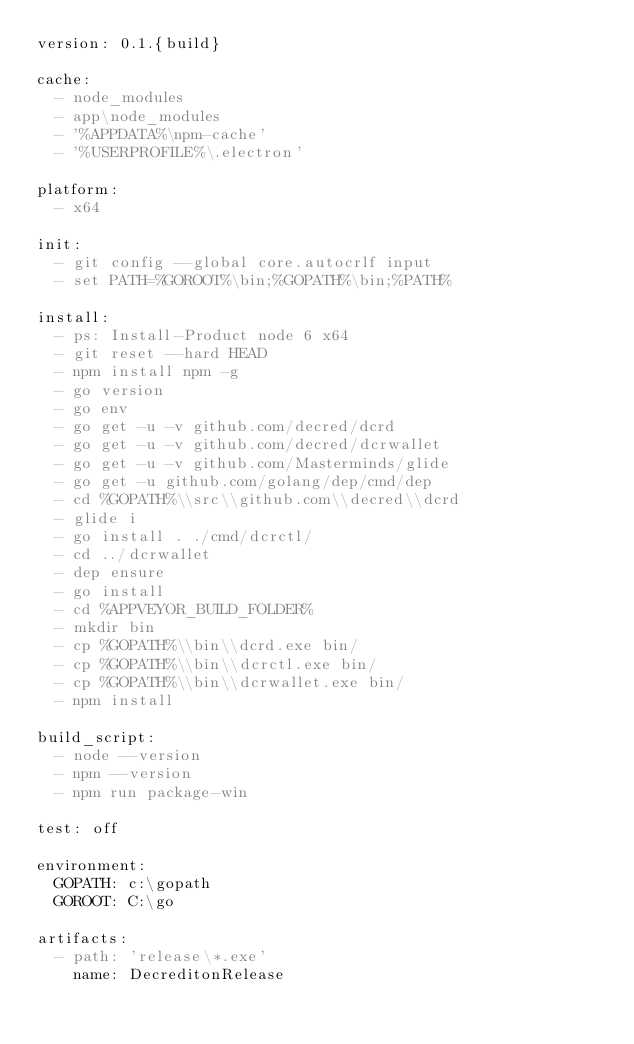Convert code to text. <code><loc_0><loc_0><loc_500><loc_500><_YAML_>version: 0.1.{build}

cache:
  - node_modules
  - app\node_modules
  - '%APPDATA%\npm-cache'
  - '%USERPROFILE%\.electron'

platform:
  - x64

init:
  - git config --global core.autocrlf input
  - set PATH=%GOROOT%\bin;%GOPATH%\bin;%PATH%

install:
  - ps: Install-Product node 6 x64
  - git reset --hard HEAD
  - npm install npm -g
  - go version
  - go env
  - go get -u -v github.com/decred/dcrd
  - go get -u -v github.com/decred/dcrwallet
  - go get -u -v github.com/Masterminds/glide
  - go get -u github.com/golang/dep/cmd/dep
  - cd %GOPATH%\\src\\github.com\\decred\\dcrd
  - glide i
  - go install . ./cmd/dcrctl/
  - cd ../dcrwallet
  - dep ensure
  - go install
  - cd %APPVEYOR_BUILD_FOLDER%
  - mkdir bin
  - cp %GOPATH%\\bin\\dcrd.exe bin/
  - cp %GOPATH%\\bin\\dcrctl.exe bin/
  - cp %GOPATH%\\bin\\dcrwallet.exe bin/
  - npm install

build_script:
  - node --version
  - npm --version
  - npm run package-win

test: off

environment:
  GOPATH: c:\gopath
  GOROOT: C:\go

artifacts:
  - path: 'release\*.exe'
    name: DecreditonRelease
</code> 